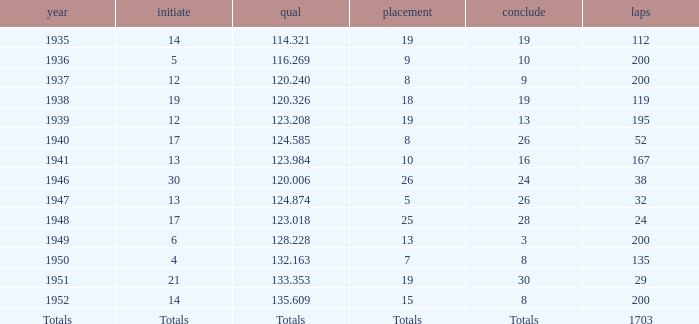In 1939, what was the finish? 13.0. 